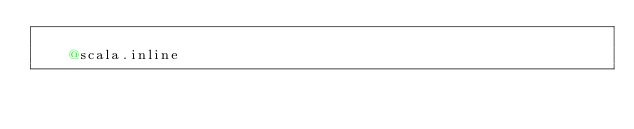Convert code to text. <code><loc_0><loc_0><loc_500><loc_500><_Scala_>    
    @scala.inline</code> 